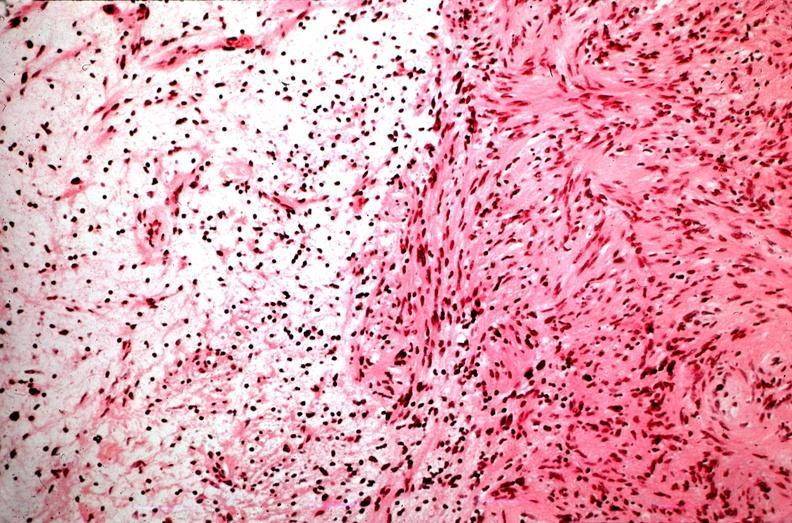where is this?
Answer the question using a single word or phrase. Nervous 